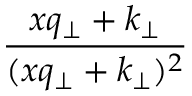Convert formula to latex. <formula><loc_0><loc_0><loc_500><loc_500>{ \frac { x q _ { \perp } + k _ { \perp } } { ( x q _ { \perp } + k _ { \perp } ) ^ { 2 } } }</formula> 